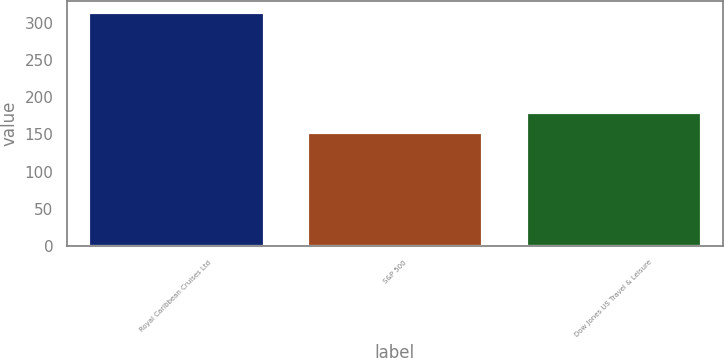<chart> <loc_0><loc_0><loc_500><loc_500><bar_chart><fcel>Royal Caribbean Cruises Ltd<fcel>S&P 500<fcel>Dow Jones US Travel & Leisure<nl><fcel>313.65<fcel>152.59<fcel>179.27<nl></chart> 